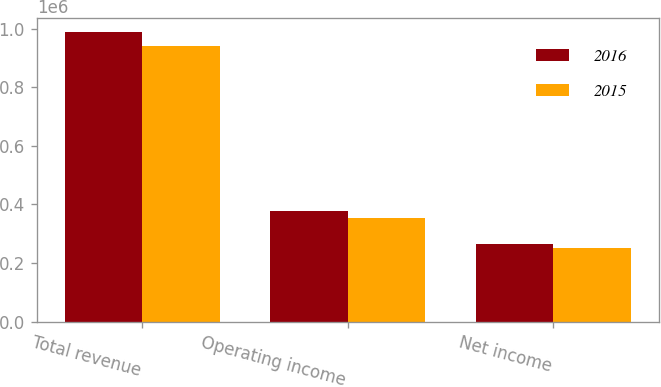<chart> <loc_0><loc_0><loc_500><loc_500><stacked_bar_chart><ecel><fcel>Total revenue<fcel>Operating income<fcel>Net income<nl><fcel>2016<fcel>988465<fcel>376242<fcel>265636<nl><fcel>2015<fcel>942753<fcel>353679<fcel>252521<nl></chart> 